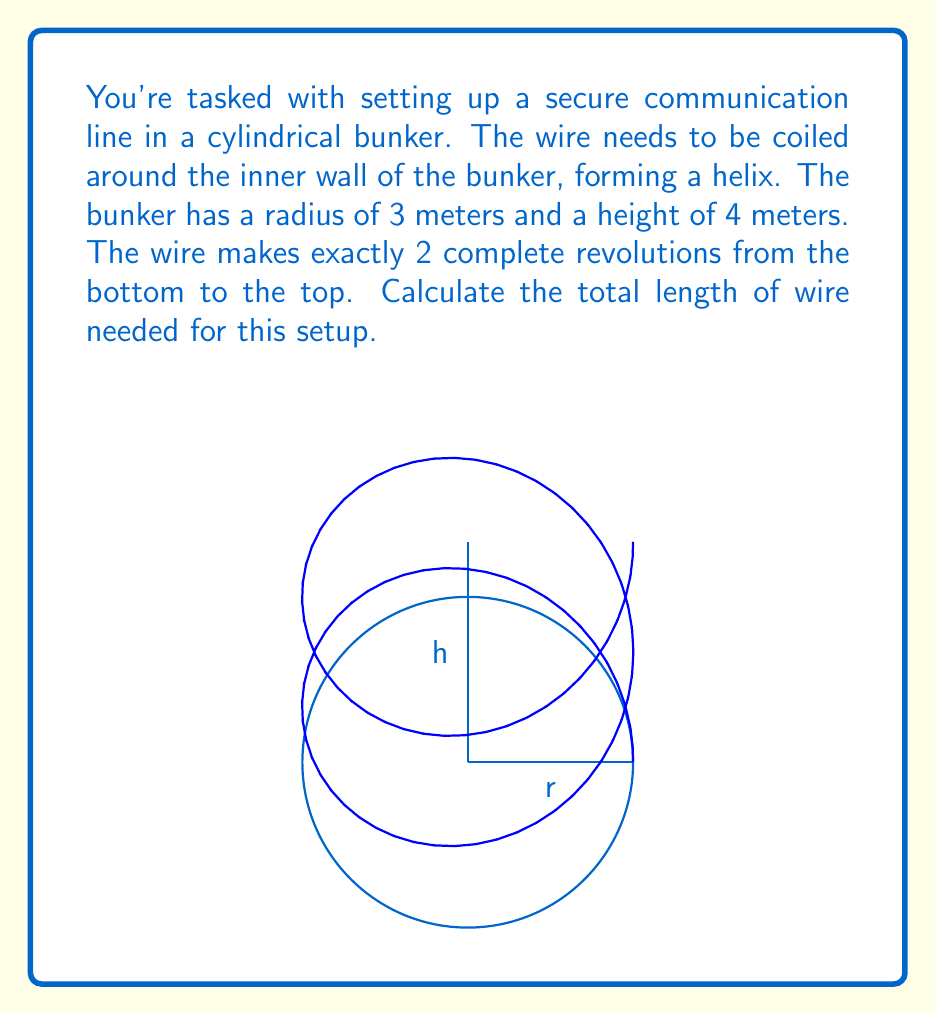Could you help me with this problem? Let's approach this step-by-step:

1) In cylindrical coordinates, a helix can be described by the parametric equations:
   $$r(t) = (r\cos(t), r\sin(t), ct)$$
   where $r$ is the radius, $t$ is the parameter, and $c$ is a constant determining the pitch of the helix.

2) We know that:
   - Radius $r = 3$ meters
   - Height $h = 4$ meters
   - Number of revolutions $n = 2$

3) To make 2 complete revolutions, $t$ must go from 0 to $4\pi$.

4) The constant $c$ can be determined from the height and number of revolutions:
   $$c = \frac{h}{4\pi} = \frac{4}{4\pi} = \frac{1}{\pi}$$

5) So, our helix is described by:
   $$r(t) = (3\cos(t), 3\sin(t), \frac{t}{\pi})$$

6) The formula for arc length of a parametric curve is:
   $$L = \int_a^b \sqrt{(\frac{dx}{dt})^2 + (\frac{dy}{dt})^2 + (\frac{dz}{dt})^2} dt$$

7) Calculating the derivatives:
   $$\frac{dx}{dt} = -3\sin(t)$$
   $$\frac{dy}{dt} = 3\cos(t)$$
   $$\frac{dz}{dt} = \frac{1}{\pi}$$

8) Substituting into the arc length formula:
   $$L = \int_0^{4\pi} \sqrt{(-3\sin(t))^2 + (3\cos(t))^2 + (\frac{1}{\pi})^2} dt$$

9) Simplifying under the square root:
   $$L = \int_0^{4\pi} \sqrt{9\sin^2(t) + 9\cos^2(t) + \frac{1}{\pi^2}} dt$$
   $$L = \int_0^{4\pi} \sqrt{9(\sin^2(t) + \cos^2(t)) + \frac{1}{\pi^2}} dt$$
   $$L = \int_0^{4\pi} \sqrt{9 + \frac{1}{\pi^2}} dt$$

10) This simplifies to:
    $$L = \sqrt{9 + \frac{1}{\pi^2}} \int_0^{4\pi} dt = 4\pi\sqrt{9 + \frac{1}{\pi^2}}$$

11) Calculating the final value:
    $$L = 4\pi\sqrt{9 + \frac{1}{\pi^2}} \approx 37.70 \text{ meters}$$
Answer: $4\pi\sqrt{9 + \frac{1}{\pi^2}} \approx 37.70$ meters 